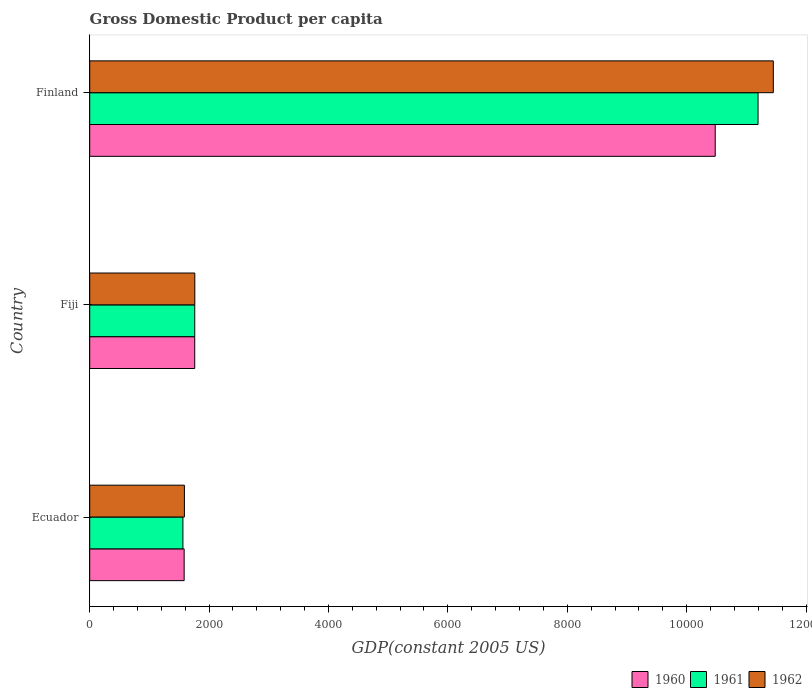How many different coloured bars are there?
Keep it short and to the point. 3. How many groups of bars are there?
Offer a terse response. 3. Are the number of bars per tick equal to the number of legend labels?
Offer a terse response. Yes. How many bars are there on the 1st tick from the top?
Your response must be concise. 3. How many bars are there on the 2nd tick from the bottom?
Keep it short and to the point. 3. What is the label of the 3rd group of bars from the top?
Give a very brief answer. Ecuador. In how many cases, is the number of bars for a given country not equal to the number of legend labels?
Offer a very short reply. 0. What is the GDP per capita in 1962 in Ecuador?
Provide a succinct answer. 1586.66. Across all countries, what is the maximum GDP per capita in 1960?
Offer a very short reply. 1.05e+04. Across all countries, what is the minimum GDP per capita in 1960?
Provide a succinct answer. 1582.31. In which country was the GDP per capita in 1960 maximum?
Your answer should be compact. Finland. In which country was the GDP per capita in 1962 minimum?
Your answer should be very brief. Ecuador. What is the total GDP per capita in 1961 in the graph?
Keep it short and to the point. 1.45e+04. What is the difference between the GDP per capita in 1961 in Fiji and that in Finland?
Offer a very short reply. -9436.37. What is the difference between the GDP per capita in 1961 in Fiji and the GDP per capita in 1960 in Ecuador?
Ensure brevity in your answer.  177.57. What is the average GDP per capita in 1960 per country?
Provide a short and direct response. 4606.85. What is the difference between the GDP per capita in 1960 and GDP per capita in 1962 in Ecuador?
Your answer should be compact. -4.35. In how many countries, is the GDP per capita in 1962 greater than 1200 US$?
Offer a terse response. 3. What is the ratio of the GDP per capita in 1962 in Ecuador to that in Finland?
Provide a succinct answer. 0.14. What is the difference between the highest and the second highest GDP per capita in 1960?
Keep it short and to the point. 8719.09. What is the difference between the highest and the lowest GDP per capita in 1960?
Provide a short and direct response. 8896.36. In how many countries, is the GDP per capita in 1961 greater than the average GDP per capita in 1961 taken over all countries?
Provide a succinct answer. 1. What does the 3rd bar from the bottom in Ecuador represents?
Provide a short and direct response. 1962. Is it the case that in every country, the sum of the GDP per capita in 1962 and GDP per capita in 1960 is greater than the GDP per capita in 1961?
Give a very brief answer. Yes. Are all the bars in the graph horizontal?
Your answer should be compact. Yes. Where does the legend appear in the graph?
Offer a terse response. Bottom right. How are the legend labels stacked?
Your answer should be very brief. Horizontal. What is the title of the graph?
Your answer should be very brief. Gross Domestic Product per capita. Does "2006" appear as one of the legend labels in the graph?
Make the answer very short. No. What is the label or title of the X-axis?
Provide a succinct answer. GDP(constant 2005 US). What is the GDP(constant 2005 US) of 1960 in Ecuador?
Make the answer very short. 1582.31. What is the GDP(constant 2005 US) in 1961 in Ecuador?
Offer a terse response. 1561.61. What is the GDP(constant 2005 US) in 1962 in Ecuador?
Ensure brevity in your answer.  1586.66. What is the GDP(constant 2005 US) in 1960 in Fiji?
Your response must be concise. 1759.58. What is the GDP(constant 2005 US) of 1961 in Fiji?
Your response must be concise. 1759.88. What is the GDP(constant 2005 US) in 1962 in Fiji?
Provide a succinct answer. 1760.96. What is the GDP(constant 2005 US) of 1960 in Finland?
Your answer should be compact. 1.05e+04. What is the GDP(constant 2005 US) of 1961 in Finland?
Offer a terse response. 1.12e+04. What is the GDP(constant 2005 US) in 1962 in Finland?
Your answer should be very brief. 1.15e+04. Across all countries, what is the maximum GDP(constant 2005 US) in 1960?
Make the answer very short. 1.05e+04. Across all countries, what is the maximum GDP(constant 2005 US) in 1961?
Provide a short and direct response. 1.12e+04. Across all countries, what is the maximum GDP(constant 2005 US) in 1962?
Give a very brief answer. 1.15e+04. Across all countries, what is the minimum GDP(constant 2005 US) in 1960?
Your answer should be compact. 1582.31. Across all countries, what is the minimum GDP(constant 2005 US) in 1961?
Offer a terse response. 1561.61. Across all countries, what is the minimum GDP(constant 2005 US) of 1962?
Provide a succinct answer. 1586.66. What is the total GDP(constant 2005 US) of 1960 in the graph?
Offer a very short reply. 1.38e+04. What is the total GDP(constant 2005 US) of 1961 in the graph?
Provide a short and direct response. 1.45e+04. What is the total GDP(constant 2005 US) of 1962 in the graph?
Your answer should be compact. 1.48e+04. What is the difference between the GDP(constant 2005 US) in 1960 in Ecuador and that in Fiji?
Your answer should be compact. -177.27. What is the difference between the GDP(constant 2005 US) of 1961 in Ecuador and that in Fiji?
Give a very brief answer. -198.26. What is the difference between the GDP(constant 2005 US) in 1962 in Ecuador and that in Fiji?
Offer a terse response. -174.3. What is the difference between the GDP(constant 2005 US) of 1960 in Ecuador and that in Finland?
Your answer should be compact. -8896.36. What is the difference between the GDP(constant 2005 US) of 1961 in Ecuador and that in Finland?
Provide a succinct answer. -9634.63. What is the difference between the GDP(constant 2005 US) of 1962 in Ecuador and that in Finland?
Keep it short and to the point. -9865.32. What is the difference between the GDP(constant 2005 US) in 1960 in Fiji and that in Finland?
Keep it short and to the point. -8719.09. What is the difference between the GDP(constant 2005 US) in 1961 in Fiji and that in Finland?
Your answer should be compact. -9436.37. What is the difference between the GDP(constant 2005 US) in 1962 in Fiji and that in Finland?
Give a very brief answer. -9691.02. What is the difference between the GDP(constant 2005 US) in 1960 in Ecuador and the GDP(constant 2005 US) in 1961 in Fiji?
Your answer should be compact. -177.57. What is the difference between the GDP(constant 2005 US) of 1960 in Ecuador and the GDP(constant 2005 US) of 1962 in Fiji?
Keep it short and to the point. -178.65. What is the difference between the GDP(constant 2005 US) of 1961 in Ecuador and the GDP(constant 2005 US) of 1962 in Fiji?
Your answer should be compact. -199.34. What is the difference between the GDP(constant 2005 US) in 1960 in Ecuador and the GDP(constant 2005 US) in 1961 in Finland?
Your answer should be very brief. -9613.94. What is the difference between the GDP(constant 2005 US) in 1960 in Ecuador and the GDP(constant 2005 US) in 1962 in Finland?
Your answer should be very brief. -9869.66. What is the difference between the GDP(constant 2005 US) of 1961 in Ecuador and the GDP(constant 2005 US) of 1962 in Finland?
Provide a succinct answer. -9890.36. What is the difference between the GDP(constant 2005 US) of 1960 in Fiji and the GDP(constant 2005 US) of 1961 in Finland?
Your response must be concise. -9436.66. What is the difference between the GDP(constant 2005 US) in 1960 in Fiji and the GDP(constant 2005 US) in 1962 in Finland?
Offer a very short reply. -9692.39. What is the difference between the GDP(constant 2005 US) of 1961 in Fiji and the GDP(constant 2005 US) of 1962 in Finland?
Your answer should be very brief. -9692.1. What is the average GDP(constant 2005 US) in 1960 per country?
Provide a short and direct response. 4606.85. What is the average GDP(constant 2005 US) of 1961 per country?
Give a very brief answer. 4839.25. What is the average GDP(constant 2005 US) of 1962 per country?
Offer a very short reply. 4933.19. What is the difference between the GDP(constant 2005 US) in 1960 and GDP(constant 2005 US) in 1961 in Ecuador?
Make the answer very short. 20.7. What is the difference between the GDP(constant 2005 US) in 1960 and GDP(constant 2005 US) in 1962 in Ecuador?
Keep it short and to the point. -4.35. What is the difference between the GDP(constant 2005 US) in 1961 and GDP(constant 2005 US) in 1962 in Ecuador?
Keep it short and to the point. -25.04. What is the difference between the GDP(constant 2005 US) in 1960 and GDP(constant 2005 US) in 1961 in Fiji?
Provide a short and direct response. -0.3. What is the difference between the GDP(constant 2005 US) of 1960 and GDP(constant 2005 US) of 1962 in Fiji?
Your answer should be compact. -1.37. What is the difference between the GDP(constant 2005 US) in 1961 and GDP(constant 2005 US) in 1962 in Fiji?
Your answer should be compact. -1.08. What is the difference between the GDP(constant 2005 US) of 1960 and GDP(constant 2005 US) of 1961 in Finland?
Offer a very short reply. -717.58. What is the difference between the GDP(constant 2005 US) in 1960 and GDP(constant 2005 US) in 1962 in Finland?
Offer a terse response. -973.3. What is the difference between the GDP(constant 2005 US) of 1961 and GDP(constant 2005 US) of 1962 in Finland?
Ensure brevity in your answer.  -255.73. What is the ratio of the GDP(constant 2005 US) of 1960 in Ecuador to that in Fiji?
Your answer should be very brief. 0.9. What is the ratio of the GDP(constant 2005 US) in 1961 in Ecuador to that in Fiji?
Provide a short and direct response. 0.89. What is the ratio of the GDP(constant 2005 US) in 1962 in Ecuador to that in Fiji?
Offer a terse response. 0.9. What is the ratio of the GDP(constant 2005 US) of 1960 in Ecuador to that in Finland?
Your response must be concise. 0.15. What is the ratio of the GDP(constant 2005 US) of 1961 in Ecuador to that in Finland?
Give a very brief answer. 0.14. What is the ratio of the GDP(constant 2005 US) in 1962 in Ecuador to that in Finland?
Offer a terse response. 0.14. What is the ratio of the GDP(constant 2005 US) of 1960 in Fiji to that in Finland?
Your response must be concise. 0.17. What is the ratio of the GDP(constant 2005 US) of 1961 in Fiji to that in Finland?
Give a very brief answer. 0.16. What is the ratio of the GDP(constant 2005 US) in 1962 in Fiji to that in Finland?
Keep it short and to the point. 0.15. What is the difference between the highest and the second highest GDP(constant 2005 US) in 1960?
Provide a succinct answer. 8719.09. What is the difference between the highest and the second highest GDP(constant 2005 US) of 1961?
Your response must be concise. 9436.37. What is the difference between the highest and the second highest GDP(constant 2005 US) of 1962?
Your response must be concise. 9691.02. What is the difference between the highest and the lowest GDP(constant 2005 US) in 1960?
Provide a short and direct response. 8896.36. What is the difference between the highest and the lowest GDP(constant 2005 US) in 1961?
Ensure brevity in your answer.  9634.63. What is the difference between the highest and the lowest GDP(constant 2005 US) of 1962?
Keep it short and to the point. 9865.32. 